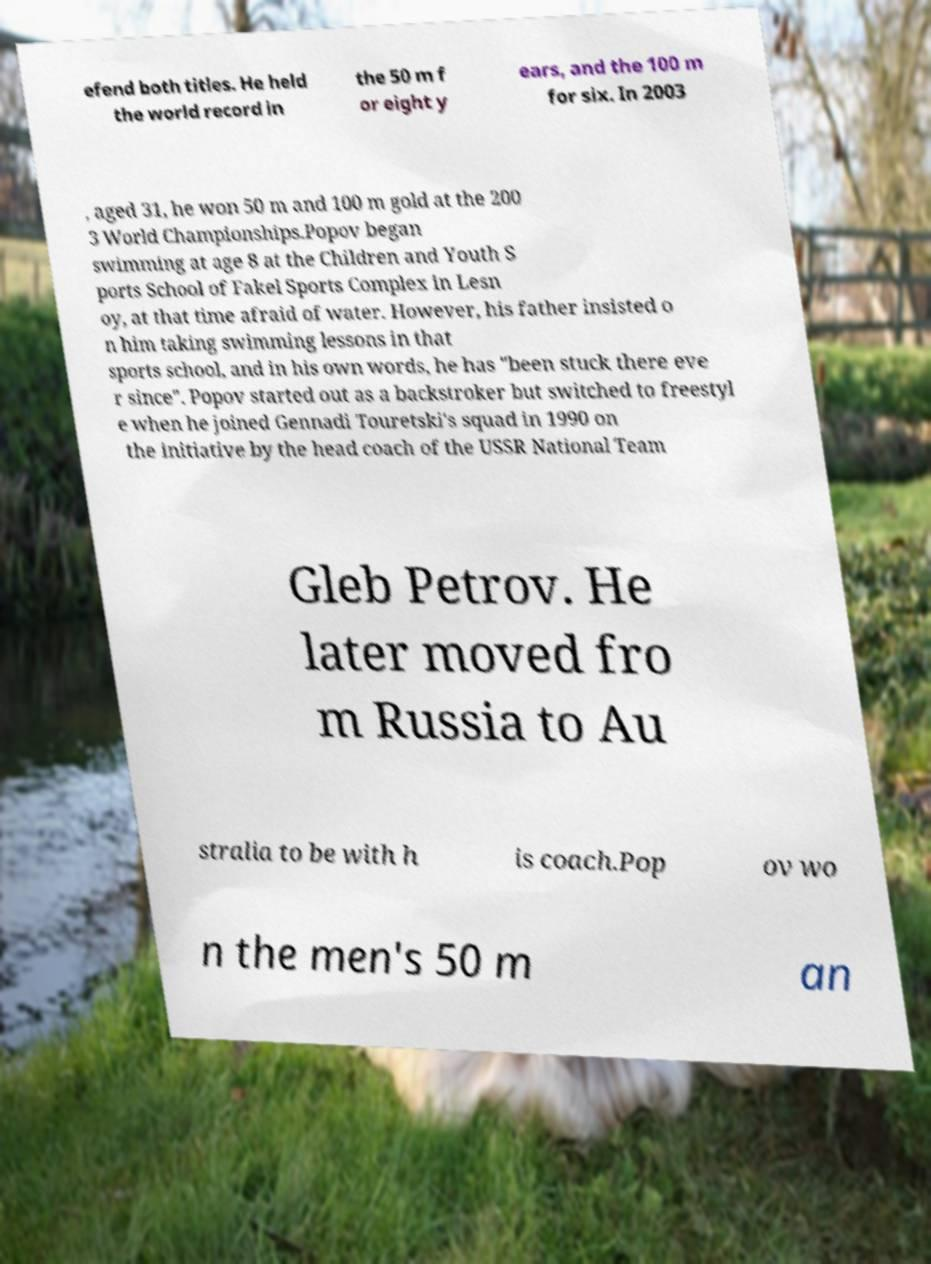What messages or text are displayed in this image? I need them in a readable, typed format. efend both titles. He held the world record in the 50 m f or eight y ears, and the 100 m for six. In 2003 , aged 31, he won 50 m and 100 m gold at the 200 3 World Championships.Popov began swimming at age 8 at the Children and Youth S ports School of Fakel Sports Complex in Lesn oy, at that time afraid of water. However, his father insisted o n him taking swimming lessons in that sports school, and in his own words, he has "been stuck there eve r since". Popov started out as a backstroker but switched to freestyl e when he joined Gennadi Touretski's squad in 1990 on the initiative by the head coach of the USSR National Team Gleb Petrov. He later moved fro m Russia to Au stralia to be with h is coach.Pop ov wo n the men's 50 m an 